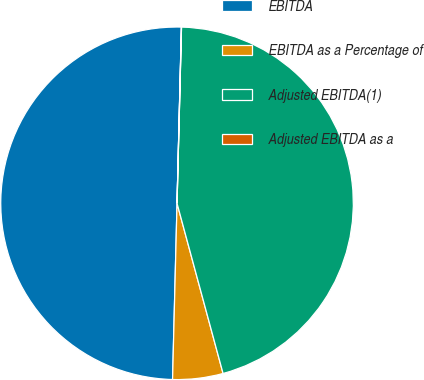Convert chart to OTSL. <chart><loc_0><loc_0><loc_500><loc_500><pie_chart><fcel>EBITDA<fcel>EBITDA as a Percentage of<fcel>Adjusted EBITDA(1)<fcel>Adjusted EBITDA as a<nl><fcel>49.99%<fcel>4.61%<fcel>45.39%<fcel>0.01%<nl></chart> 